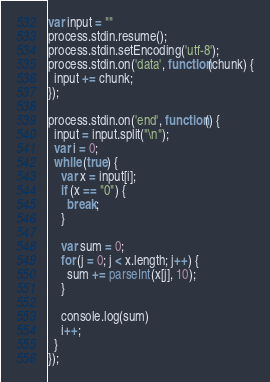Convert code to text. <code><loc_0><loc_0><loc_500><loc_500><_JavaScript_>var input = ""
process.stdin.resume();
process.stdin.setEncoding('utf-8');
process.stdin.on('data', function(chunk) {
  input += chunk;
});
 
process.stdin.on('end', function() {
  input = input.split("\n");
  var i = 0;
  while (true) {
    var x = input[i];
    if (x == "0") {
      break;
    }

    var sum = 0;
    for (j = 0; j < x.length; j++) {
      sum += parseInt(x[j], 10);
    }

    console.log(sum)
    i++;
  }
});</code> 